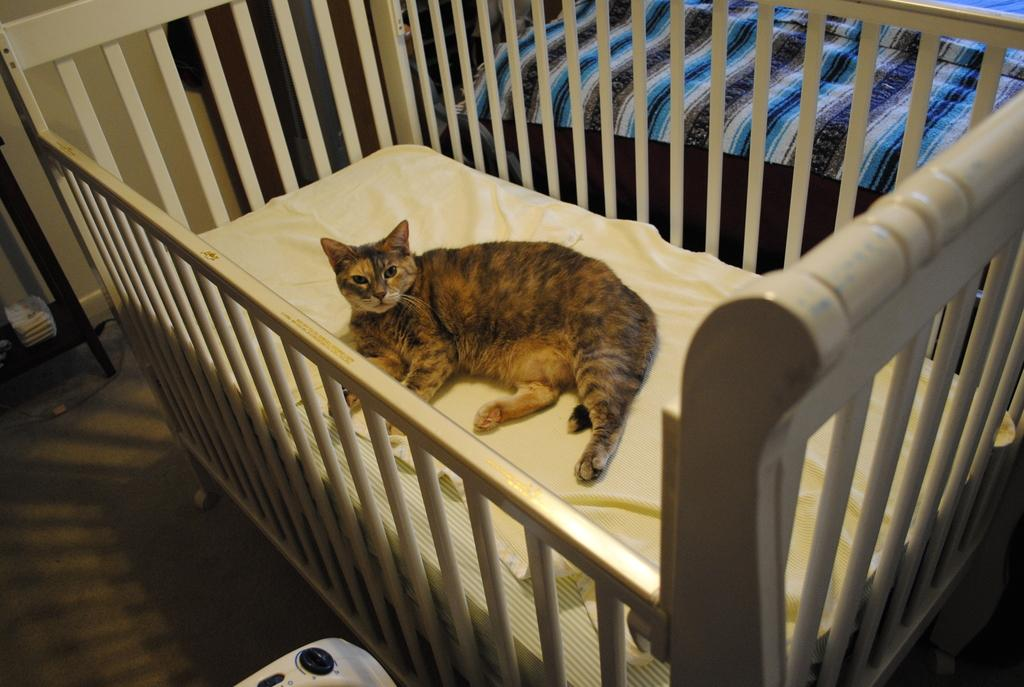What is the main object in the image? There is a cradle in the image. What is on the cradle? A cat is on the cradle. What can be seen below the cradle? The floor is visible in the image. Can you hear the honey talking to the cat in the image? There is no honey or talking in the image; it features a cat on a cradle and a visible floor. 